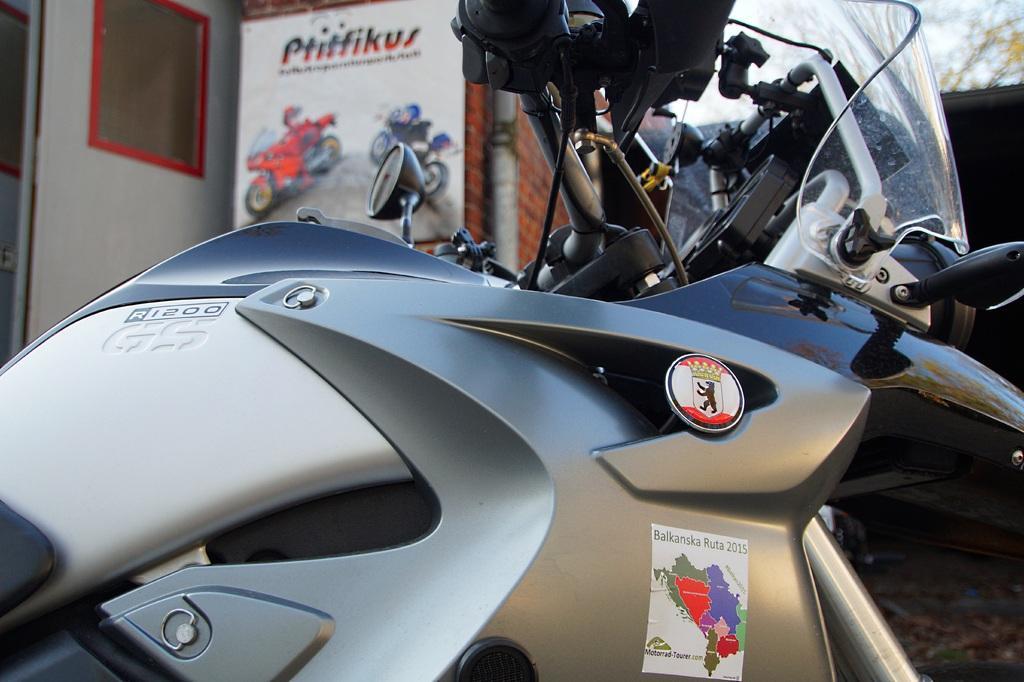Could you give a brief overview of what you see in this image? In the given image i can see a bike and in the background i can see a board. 